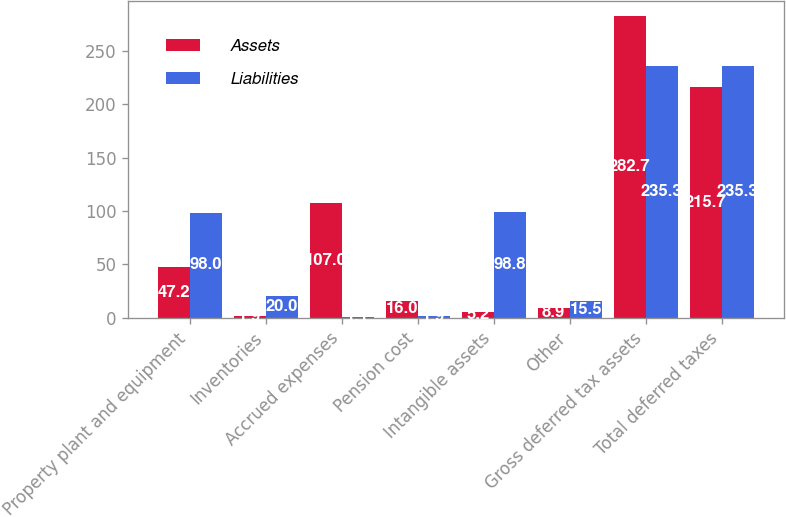<chart> <loc_0><loc_0><loc_500><loc_500><stacked_bar_chart><ecel><fcel>Property plant and equipment<fcel>Inventories<fcel>Accrued expenses<fcel>Pension cost<fcel>Intangible assets<fcel>Other<fcel>Gross deferred tax assets<fcel>Total deferred taxes<nl><fcel>Assets<fcel>47.2<fcel>1.9<fcel>107<fcel>16<fcel>5.2<fcel>8.9<fcel>282.7<fcel>215.7<nl><fcel>Liabilities<fcel>98<fcel>20<fcel>1.1<fcel>1.9<fcel>98.8<fcel>15.5<fcel>235.3<fcel>235.3<nl></chart> 